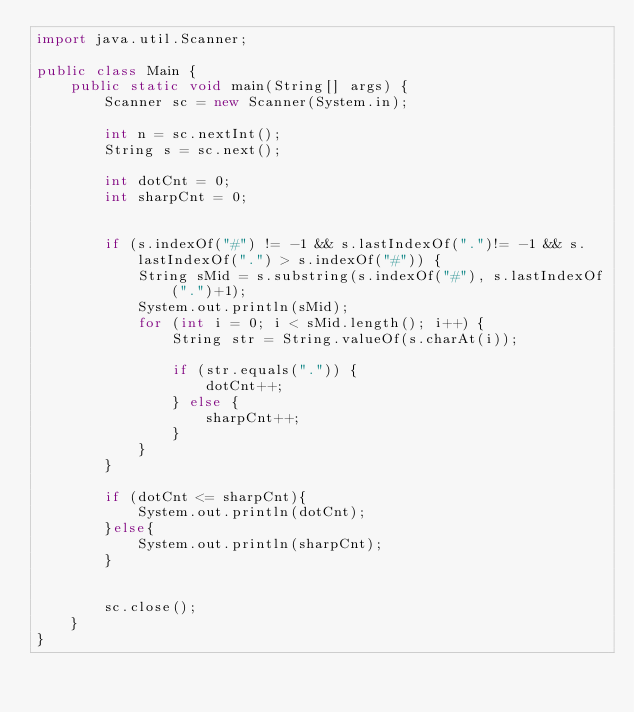Convert code to text. <code><loc_0><loc_0><loc_500><loc_500><_Java_>import java.util.Scanner;

public class Main {
    public static void main(String[] args) {
        Scanner sc = new Scanner(System.in);

        int n = sc.nextInt();
        String s = sc.next();

        int dotCnt = 0;
        int sharpCnt = 0;


        if (s.indexOf("#") != -1 && s.lastIndexOf(".")!= -1 && s.lastIndexOf(".") > s.indexOf("#")) {
            String sMid = s.substring(s.indexOf("#"), s.lastIndexOf(".")+1);
            System.out.println(sMid);
            for (int i = 0; i < sMid.length(); i++) {
                String str = String.valueOf(s.charAt(i));

                if (str.equals(".")) {
                    dotCnt++;
                } else {
                    sharpCnt++;
                }
            }
        }

        if (dotCnt <= sharpCnt){
            System.out.println(dotCnt);
        }else{
            System.out.println(sharpCnt);
        }


        sc.close();
    }
}</code> 